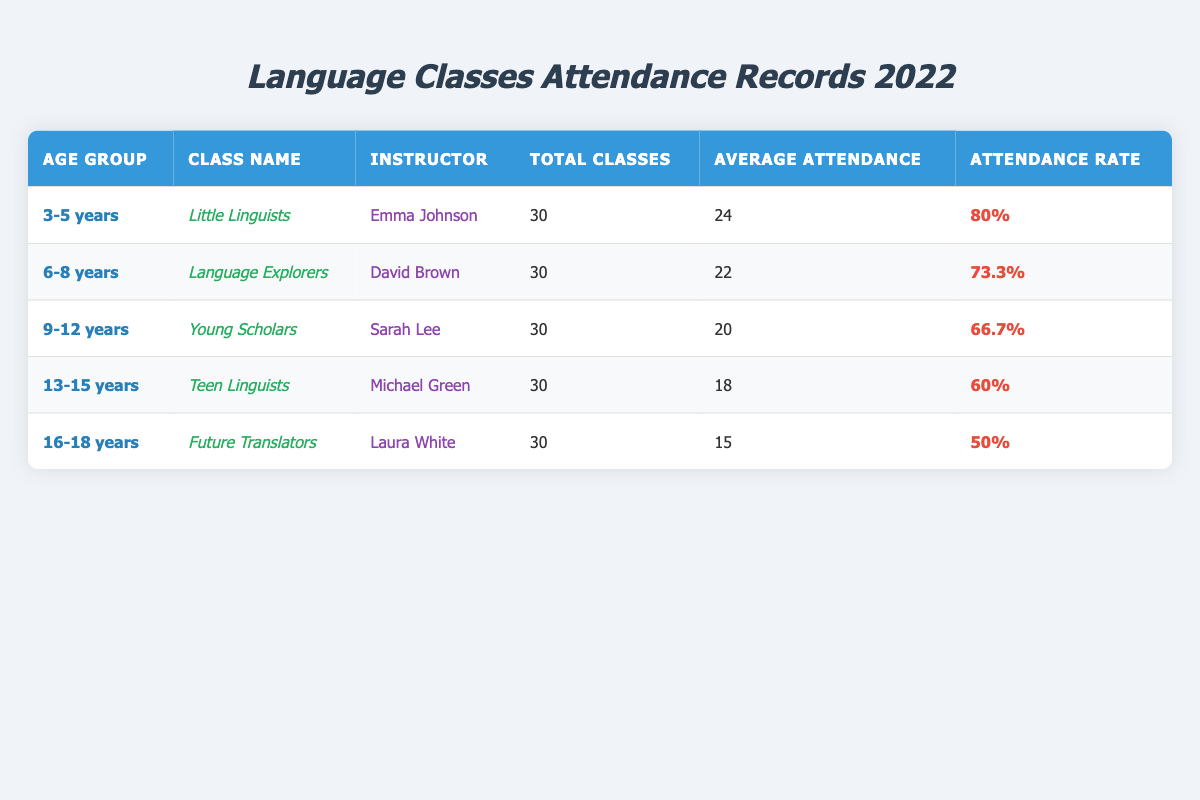What is the total number of classes for the "Language Explorers" group? The table lists the "Language Explorers" class under the "6-8 years" age group, and it shows "Total Classes" as 30.
Answer: 30 Which age group has the highest average attendance? The age groups and their average attendance values are: 3-5 years (24), 6-8 years (22), 9-12 years (20), 13-15 years (18), and 16-18 years (15). The highest average attendance is 24 corresponding to the 3-5 years age group.
Answer: 3-5 years What is the attendance rate for the "Teen Linguists" class? Looking under the "13-15 years" age group, the attendance rate for the "Teen Linguists" class is listed as 60%.
Answer: 60% How many attendees, on average, are present in the "Future Translators" class? The average attendance value for the "Future Translators" class, which falls into the "16-18 years" age group, is 15.
Answer: 15 What is the difference in average attendance between the 6-8 years and the 9-12 years age groups? The average attendance for the 6-8 years group is 22, and for the 9-12 years group, it is 20. The difference is 22 - 20 = 2.
Answer: 2 Is the attendance rate for the "Little Linguists" class above 75%? The attendance rate for the "Little Linguists" class is 80%, which is greater than 75%.
Answer: Yes Which age group has the lowest attendance rate and what is it? The attendance rates for the groups are: 80% (3-5 years), 73.3% (6-8 years), 66.7% (9-12 years), 60% (13-15 years), and 50% (16-18 years). The lowest rate is 50% for the 16-18 years age group.
Answer: 16-18 years, 50% If we combine the average attendance of all age groups, what would be the total? The average attendances are: 24 (3-5 years) + 22 (6-8 years) + 20 (9-12 years) + 18 (13-15 years) + 15 (16-18 years) giving a total of 24 + 22 + 20 + 18 + 15 = 99.
Answer: 99 What percentage of the total classes were attended on average in the "Young Scholars" group? The "Young Scholars" class conducted 30 total classes with an average attendance of 20. The attendance percentage is (20/30) * 100 = 66.7%.
Answer: 66.7% Which instructor had the highest average attendance in their class? Instructor Emma Johnson taught the "Little Linguists" class, which had the highest average attendance of 24. No other class reaches this value.
Answer: Emma Johnson 